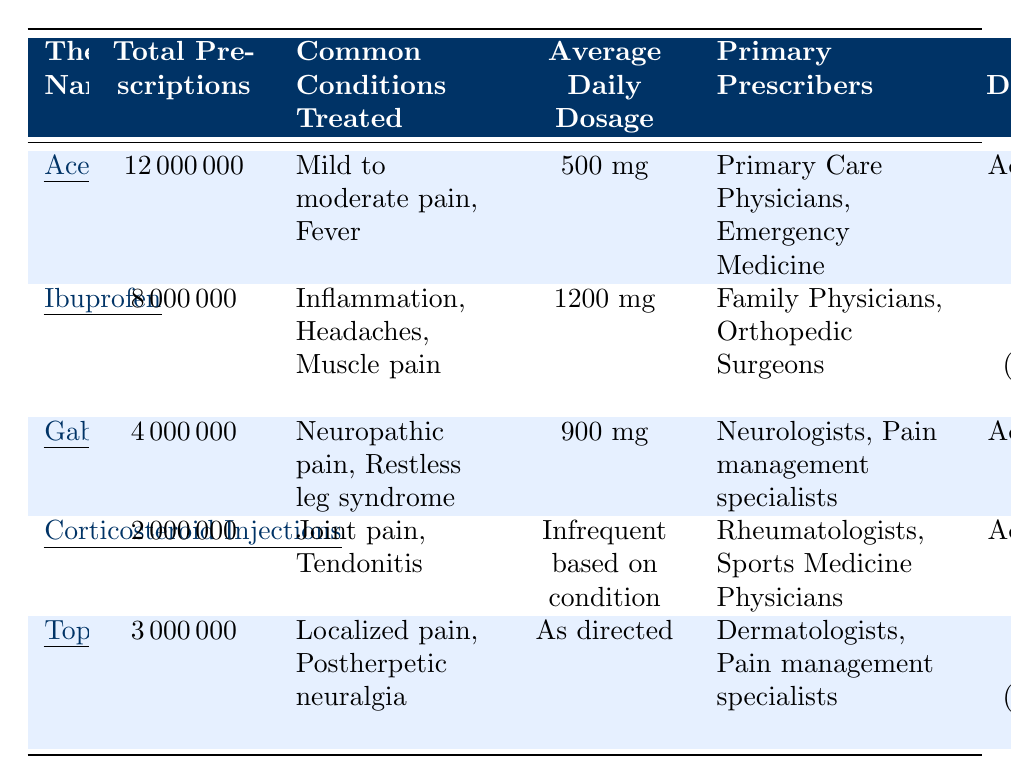What is the total number of prescriptions for Acetaminophen? The table shows that Acetaminophen has a total of 12,000,000 prescriptions listed.
Answer: 12,000,000 Which therapy is prescribed the most? Acetaminophen is listed as having the highest total prescriptions at 12,000,000, compared to the others.
Answer: Acetaminophen What are the common conditions treated by Ibuprofen? The table indicates that Ibuprofen is used to treat inflammation, headaches, and muscle pain.
Answer: Inflammation, headaches, muscle pain What is the average daily dosage for Gabapentin? Gabapentin has an average daily dosage listed as 900 mg in the table.
Answer: 900 mg Which therapy has the lowest total number of prescriptions? Corticosteroid Injections has the lowest total prescriptions at 2,000,000 when compared with the other therapies listed.
Answer: Corticosteroid Injections Are more prescriptions written for Topical Analgesics than for Gabapentin? The total prescriptions for Topical Analgesics is 3,000,000, which is greater than Gabapentin's 4,000,000, hence the statement is false.
Answer: No What percentage of male patients are prescribed Gabapentin? According to the table, Gabapentin is prescribed to 40% male patients.
Answer: 40% Are Dermatologists the primary prescribers for Topical Analgesics? The table states that Dermatologists are listed as primary prescribers for Topical Analgesics, making the statement true.
Answer: Yes How many total prescriptions are for non-opioid therapies (sum all)? Total prescriptions can be calculated by adding each therapy: 12,000,000 (Acetaminophen) + 8,000,000 (Ibuprofen) + 4,000,000 (Gabapentin) + 2,000,000 (Corticosteroid Injections) + 3,000,000 (Topical Analgesics) = 29,000,000.
Answer: 29,000,000 What is the average daily dosage of Ibuprofen compared to Acetaminophen? Ibuprofen's average daily dosage is 1200 mg and Acetaminophen's is 500 mg. Thus, Ibuprofen has a higher average daily dosage.
Answer: Ibuprofen is higher What is the gender distribution for patients taking Corticosteroid Injections? The table shows that for Corticosteroid Injections, the gender distribution is 55% male and 45% female.
Answer: 55% male, 45% female Is Gabapentin primarily prescribed by family physicians? The table indicates that Neurologists and Pain management specialists are the primary prescribers for Gabapentin, thus the statement is false.
Answer: No What is the average daily dosage for corticosteroid injections? The average daily dosage for corticosteroid injections is not listed as a fixed amount; it says it's based on condition.
Answer: Infrequent based on condition 